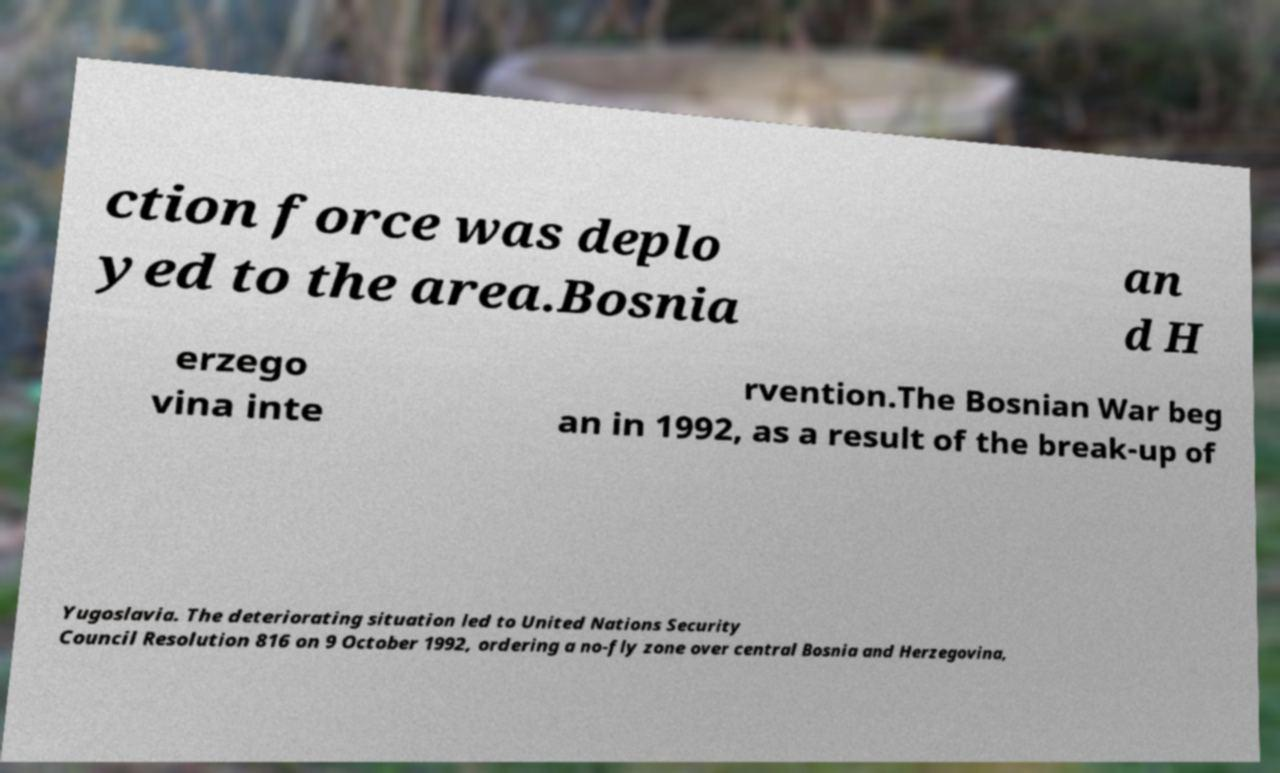Please identify and transcribe the text found in this image. ction force was deplo yed to the area.Bosnia an d H erzego vina inte rvention.The Bosnian War beg an in 1992, as a result of the break-up of Yugoslavia. The deteriorating situation led to United Nations Security Council Resolution 816 on 9 October 1992, ordering a no-fly zone over central Bosnia and Herzegovina, 